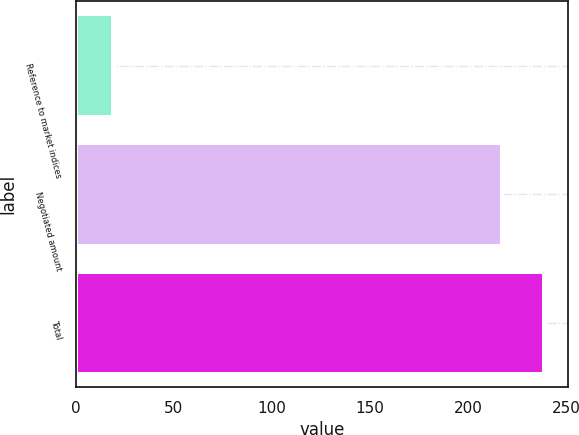<chart> <loc_0><loc_0><loc_500><loc_500><bar_chart><fcel>Reference to market indices<fcel>Negotiated amount<fcel>Total<nl><fcel>19<fcel>217<fcel>238.7<nl></chart> 